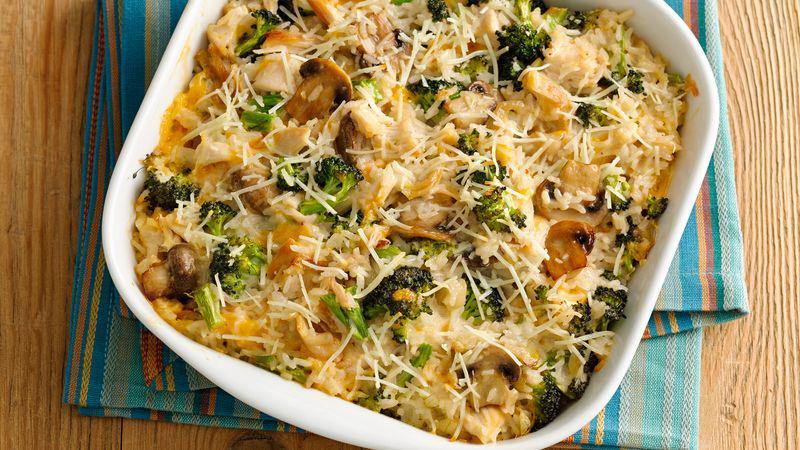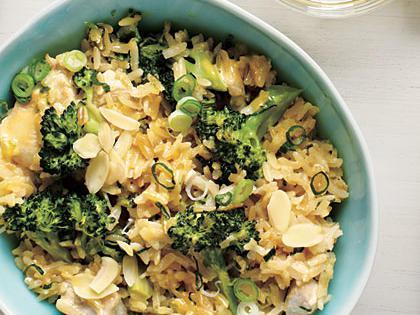The first image is the image on the left, the second image is the image on the right. Assess this claim about the two images: "There is a fork on one of the images.". Correct or not? Answer yes or no. No. 